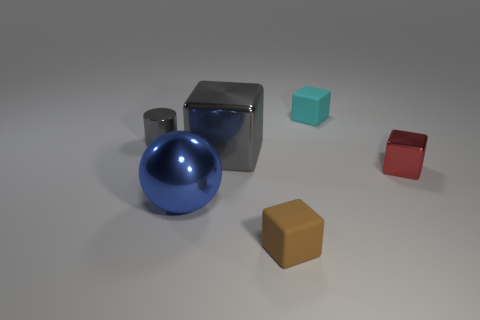How many big metallic cubes are behind the big object that is to the left of the metal block on the left side of the small red object?
Provide a short and direct response. 1. What is the material of the tiny block to the left of the block behind the large gray thing?
Your answer should be compact. Rubber. Is there another small gray object that has the same shape as the tiny gray thing?
Give a very brief answer. No. There is a metal cylinder that is the same size as the cyan object; what color is it?
Offer a terse response. Gray. What number of things are either small gray things in front of the cyan matte thing or objects that are in front of the gray cylinder?
Provide a succinct answer. 5. How many objects are large brown metal balls or tiny metal things?
Offer a very short reply. 2. What size is the block that is both behind the small shiny block and in front of the cyan cube?
Provide a succinct answer. Large. What number of large blocks are made of the same material as the small red block?
Your answer should be compact. 1. What is the color of the other small object that is the same material as the tiny gray object?
Provide a short and direct response. Red. There is a tiny metallic thing to the left of the tiny red thing; does it have the same color as the big metal cube?
Offer a terse response. Yes. 